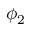<formula> <loc_0><loc_0><loc_500><loc_500>\phi _ { 2 }</formula> 